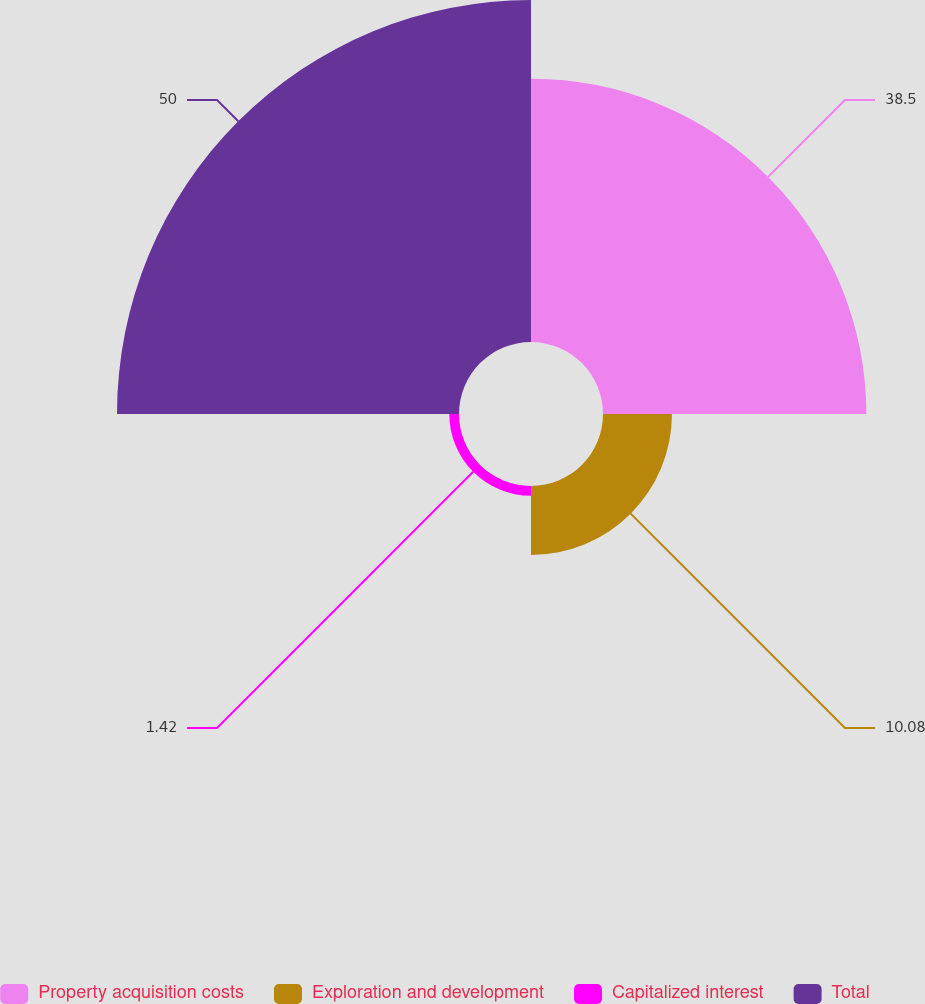Convert chart to OTSL. <chart><loc_0><loc_0><loc_500><loc_500><pie_chart><fcel>Property acquisition costs<fcel>Exploration and development<fcel>Capitalized interest<fcel>Total<nl><fcel>38.5%<fcel>10.08%<fcel>1.42%<fcel>50.0%<nl></chart> 